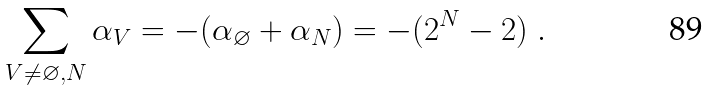<formula> <loc_0><loc_0><loc_500><loc_500>\sum _ { V \neq \varnothing , N } \alpha _ { V } = - ( \alpha _ { \varnothing } + \alpha _ { N } ) = - ( 2 ^ { N } - 2 ) \ .</formula> 